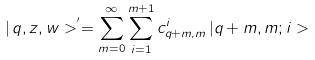Convert formula to latex. <formula><loc_0><loc_0><loc_500><loc_500>| \, q , z , w > ^ { ^ { \prime } } = \sum _ { m = 0 } ^ { \infty } \sum _ { i = 1 } ^ { m + 1 } c _ { q + m , m } ^ { i } \, | q + m , m ; i ></formula> 